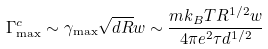Convert formula to latex. <formula><loc_0><loc_0><loc_500><loc_500>\Gamma _ { \max } ^ { c } \sim \gamma _ { \max } \sqrt { d R } w \sim \frac { m k _ { B } T R ^ { 1 / 2 } w } { 4 \pi e ^ { 2 } \tau d ^ { 1 / 2 } }</formula> 